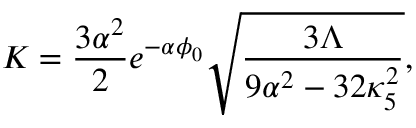<formula> <loc_0><loc_0><loc_500><loc_500>K = { \frac { 3 \alpha ^ { 2 } } { 2 } } e ^ { - \alpha \phi _ { 0 } } \sqrt { \frac { 3 \Lambda } { 9 \alpha ^ { 2 } - 3 2 \kappa _ { 5 } ^ { 2 } } } ,</formula> 